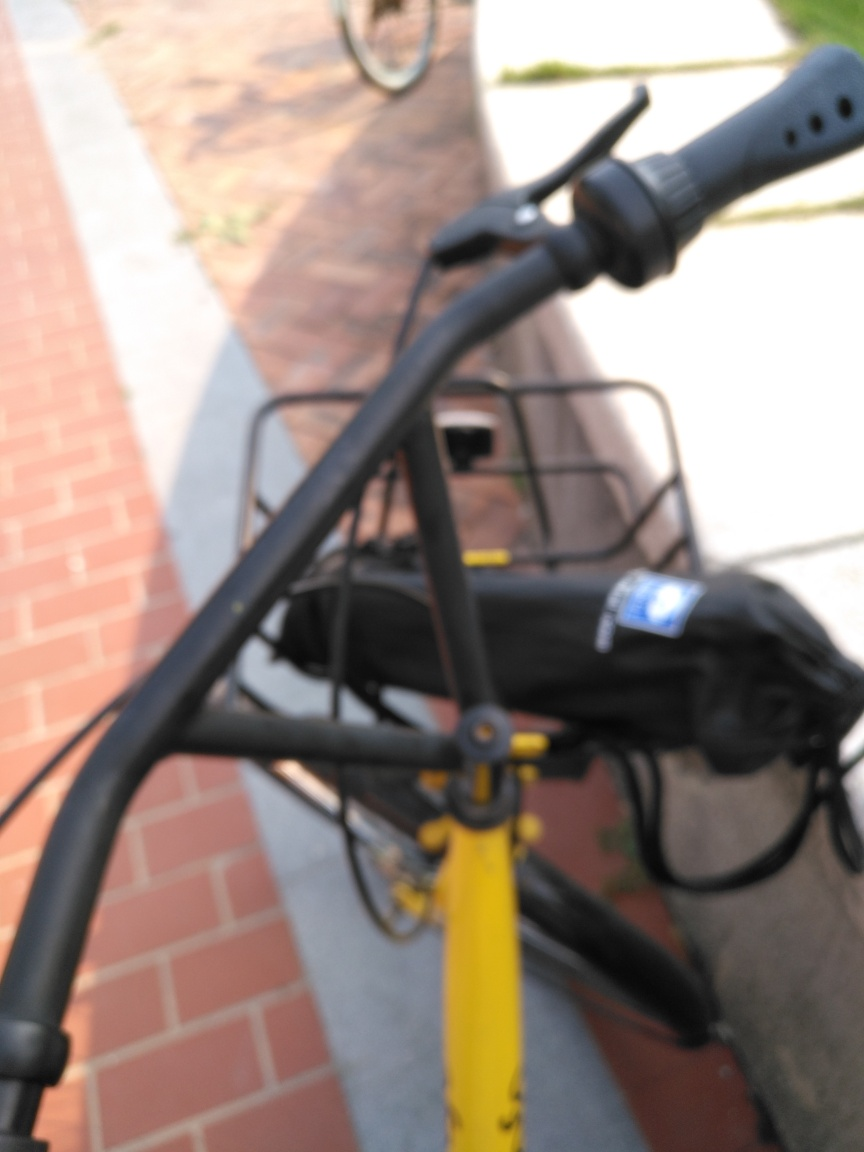Can you identify any specific characteristics of the bike shown? Specific details of the bike are difficult to discern due to the blur, but it seems to have a distinctive yellow frame, possibly indicating a shared city bike or a bike with a unique custom color. There's also a basket attached to the handlebars, suggesting utility for carrying items. Is there anything unique about the photo's composition? The photo stands out due to its blurred focus, which is not commonly seen in typical sharp photography. This effect may be intentional to convey a message or may be the result of a candid snapshot taken in a rush. 